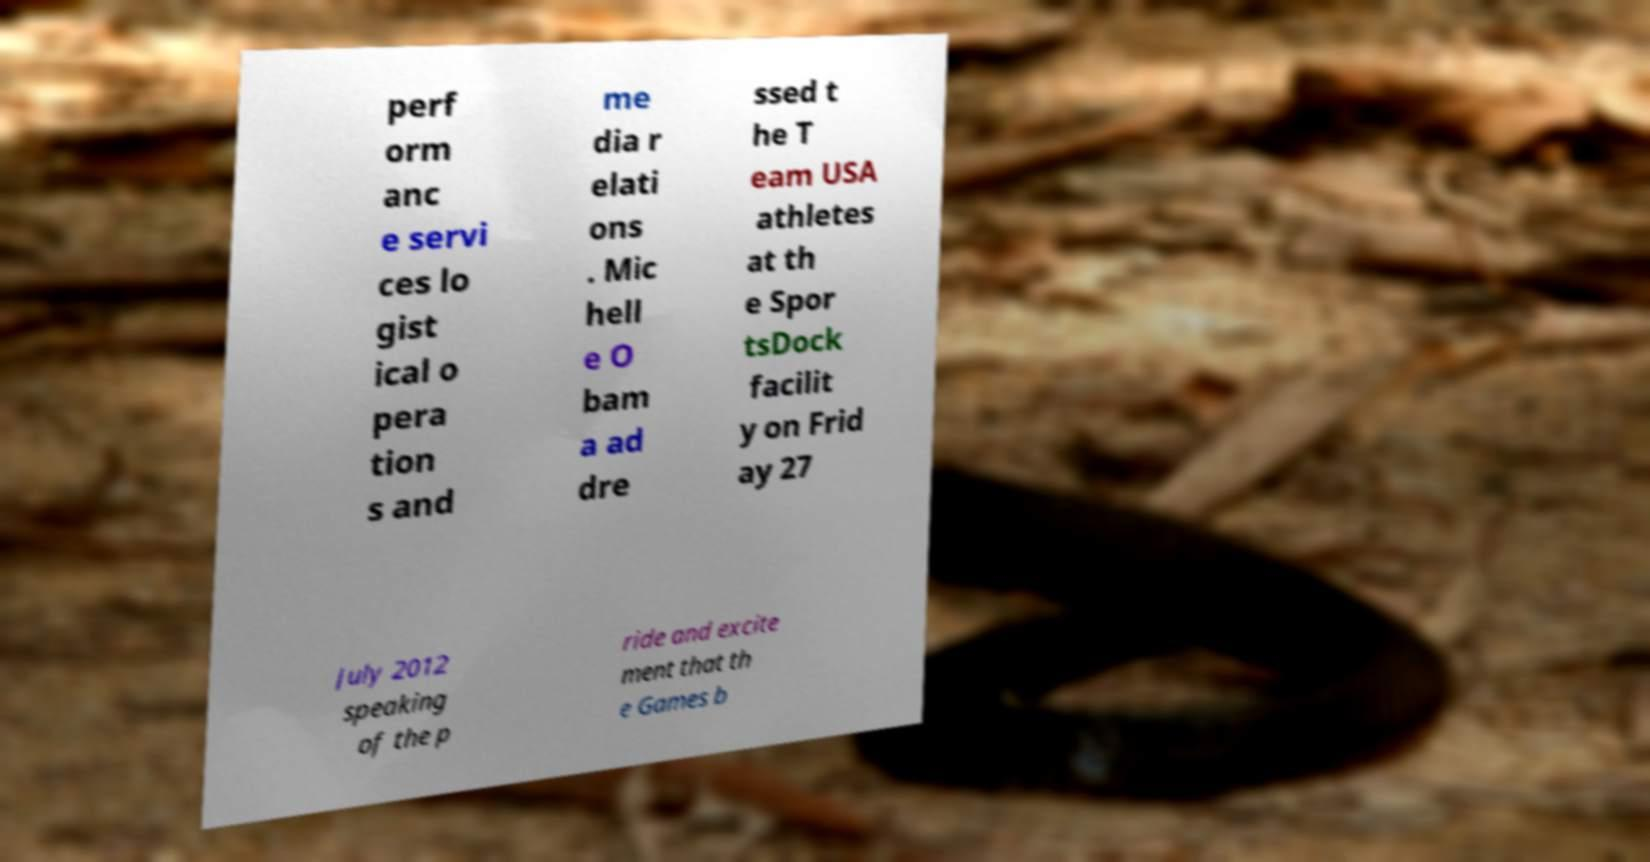I need the written content from this picture converted into text. Can you do that? perf orm anc e servi ces lo gist ical o pera tion s and me dia r elati ons . Mic hell e O bam a ad dre ssed t he T eam USA athletes at th e Spor tsDock facilit y on Frid ay 27 July 2012 speaking of the p ride and excite ment that th e Games b 